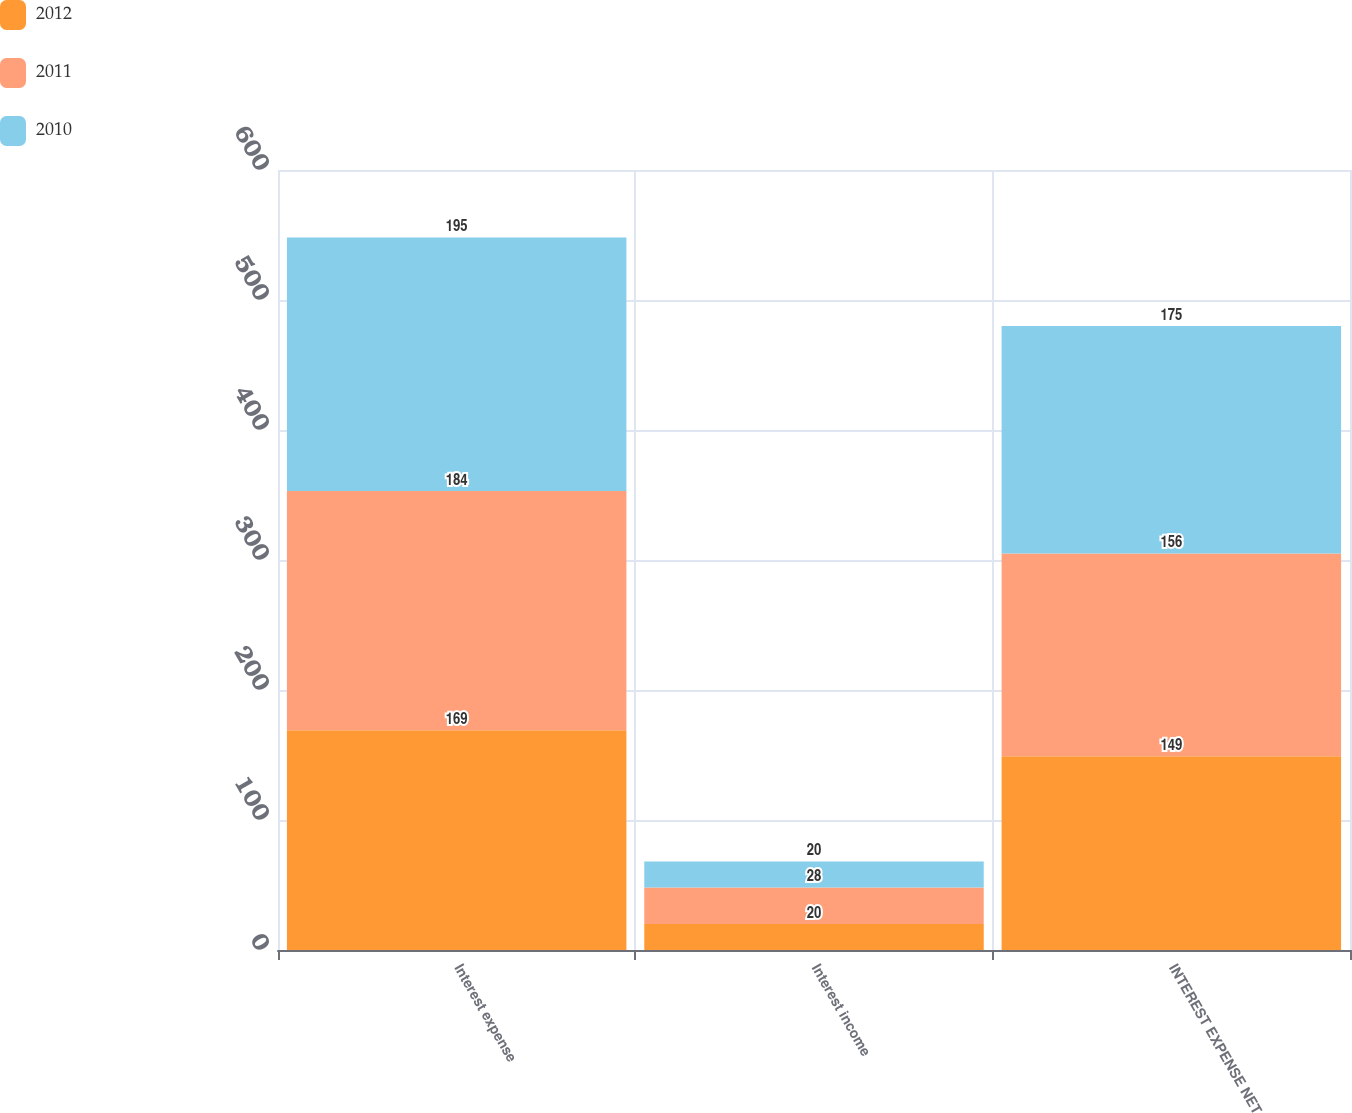Convert chart. <chart><loc_0><loc_0><loc_500><loc_500><stacked_bar_chart><ecel><fcel>Interest expense<fcel>Interest income<fcel>INTEREST EXPENSE NET<nl><fcel>2012<fcel>169<fcel>20<fcel>149<nl><fcel>2011<fcel>184<fcel>28<fcel>156<nl><fcel>2010<fcel>195<fcel>20<fcel>175<nl></chart> 